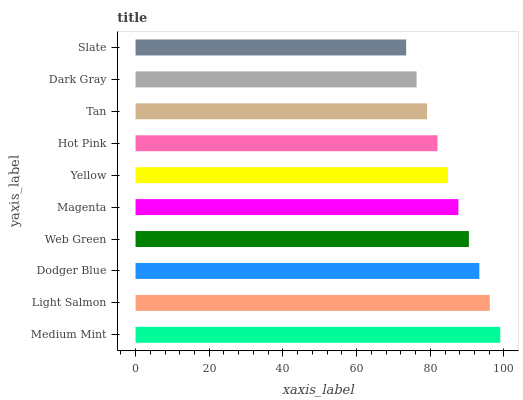Is Slate the minimum?
Answer yes or no. Yes. Is Medium Mint the maximum?
Answer yes or no. Yes. Is Light Salmon the minimum?
Answer yes or no. No. Is Light Salmon the maximum?
Answer yes or no. No. Is Medium Mint greater than Light Salmon?
Answer yes or no. Yes. Is Light Salmon less than Medium Mint?
Answer yes or no. Yes. Is Light Salmon greater than Medium Mint?
Answer yes or no. No. Is Medium Mint less than Light Salmon?
Answer yes or no. No. Is Magenta the high median?
Answer yes or no. Yes. Is Yellow the low median?
Answer yes or no. Yes. Is Light Salmon the high median?
Answer yes or no. No. Is Dark Gray the low median?
Answer yes or no. No. 